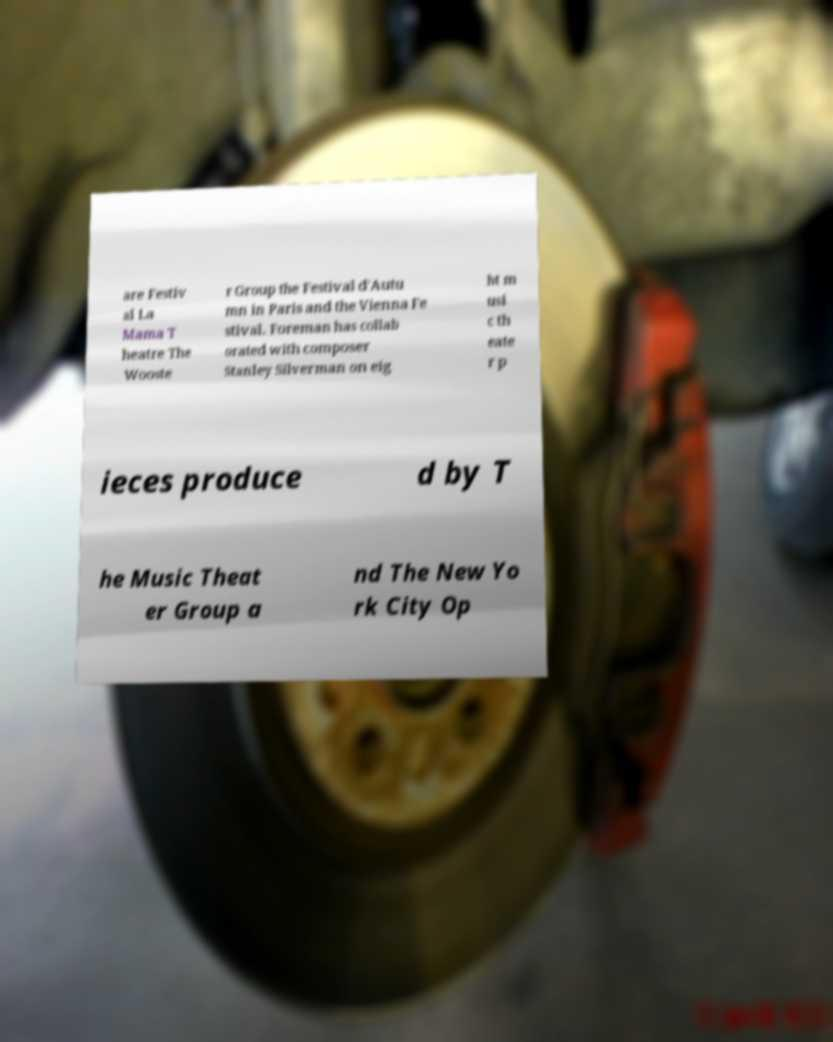Please identify and transcribe the text found in this image. are Festiv al La Mama T heatre The Wooste r Group the Festival d'Autu mn in Paris and the Vienna Fe stival. Foreman has collab orated with composer Stanley Silverman on eig ht m usi c th eate r p ieces produce d by T he Music Theat er Group a nd The New Yo rk City Op 